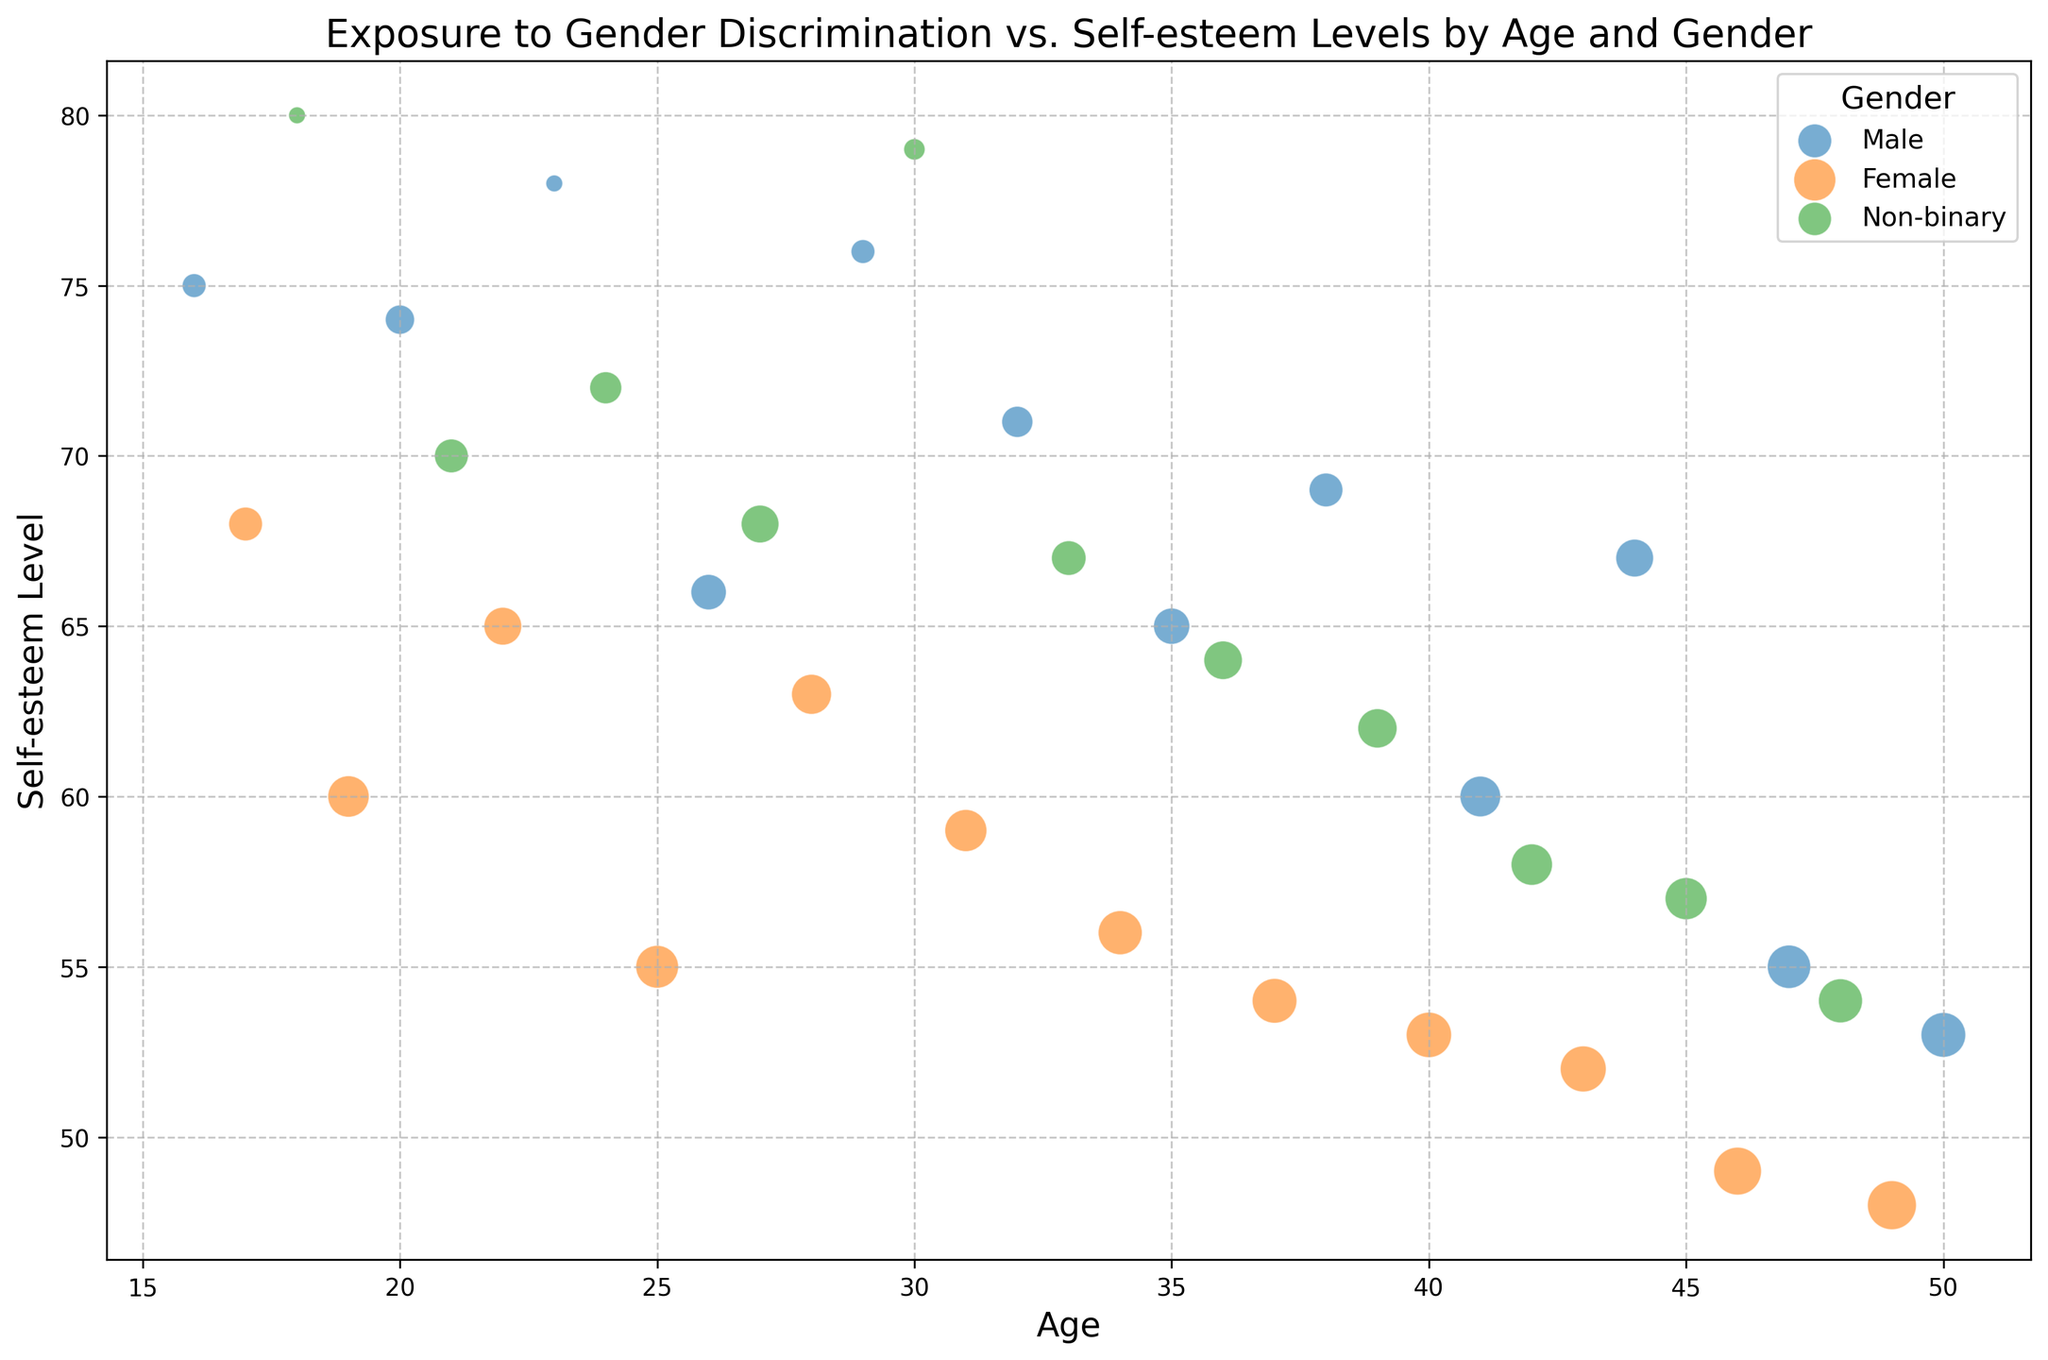What is the general relationship between exposure to gender discrimination and self-esteem levels across all ages and genders? By visually examining the plot, it appears that higher levels of exposure to gender discrimination (represented by larger bubbles) are generally associated with lower self-esteem levels. This trend is visible in all gender categories.
Answer: Higher exposure tends to correlate with lower self-esteem Among the three genders, which one exhibits the largest bubbles (highest exposure to gender discrimination) in the older age group (40-50)? Observing the plot, the largest bubbles within the age range 40-50 are predominantly associated with females. The bubbles for females tend to be larger than those for males and non-binary individuals in this age group.
Answer: Female How does the self-esteem level for females change with age between 16 and 50? By tracing the trajectory of the female data points (bubbles in the plot) from age 16 to 50, we notice a consistent decline in self-esteem levels as age increases. The bubbles decrease in self-esteem level with increasing age.
Answer: It decreases Which age has the highest self-esteem level among non-binary individuals, and what is their exposure to gender discrimination? The highest self-esteem level for non-binary individuals can be identified by finding the bubble representing non-binary individuals with the highest position on the y-axis. This occurs at age 18, with a self-esteem level of 80 and an exposure to gender discrimination of 0.5.
Answer: Age 18, exposure 0.5 Compare the self-esteem levels of 25-year-old females and 25-year-old males. What can you infer? The self-esteem levels for females and males at age 25 can be located by finding the corresponding bubble positions. A 25-year-old female has a self-esteem level of 55, while a 25-year-old male has a self-esteem level of 66. Thus, at age 25, males generally have higher self-esteem levels than females.
Answer: Males have higher self-esteem How does the exposure to gender discrimination differ between males and females aged 45 and what are their respective self-esteem levels? By locating the bubbles for 45-year-old males and females, we note that males have an exposure level of 3.5 and females have a level of 4.0. Correspondingly, their self-esteem levels are 53 for males and 49 for females, indicating higher exposure and lower self-esteem for females.
Answer: Males: 3.5, 53; Females: 4.0, 49 Examine the trend of self-esteem levels for males between ages 20 and 40. Are there any notable patterns? By tracking the positions of male bubbles along the age axis from 20 to 40, there is a noticeable pattern where the self-esteem levels fluctuate but tend to decline overall. Some fluctuations are seen around age 25 and mid-30s.
Answer: Fluctuating but generally declining Which gender has the most data points clustered around high self-esteem levels (70 and above) across the entire age range? Observing the distribution of bubble positions, non-binary individuals have the most bubbles located above the self-esteem level of 70, indicating they more frequently report higher self-esteem levels.
Answer: Non-binary Between ages 30 and 40, which gender has the widest range of exposure to discrimination? By examining the bubble sizes for each gender within the 30-40 age range, females exhibit the widest range, with large and small bubbles showing significant variation in exposure to gender discrimination.
Answer: Female 